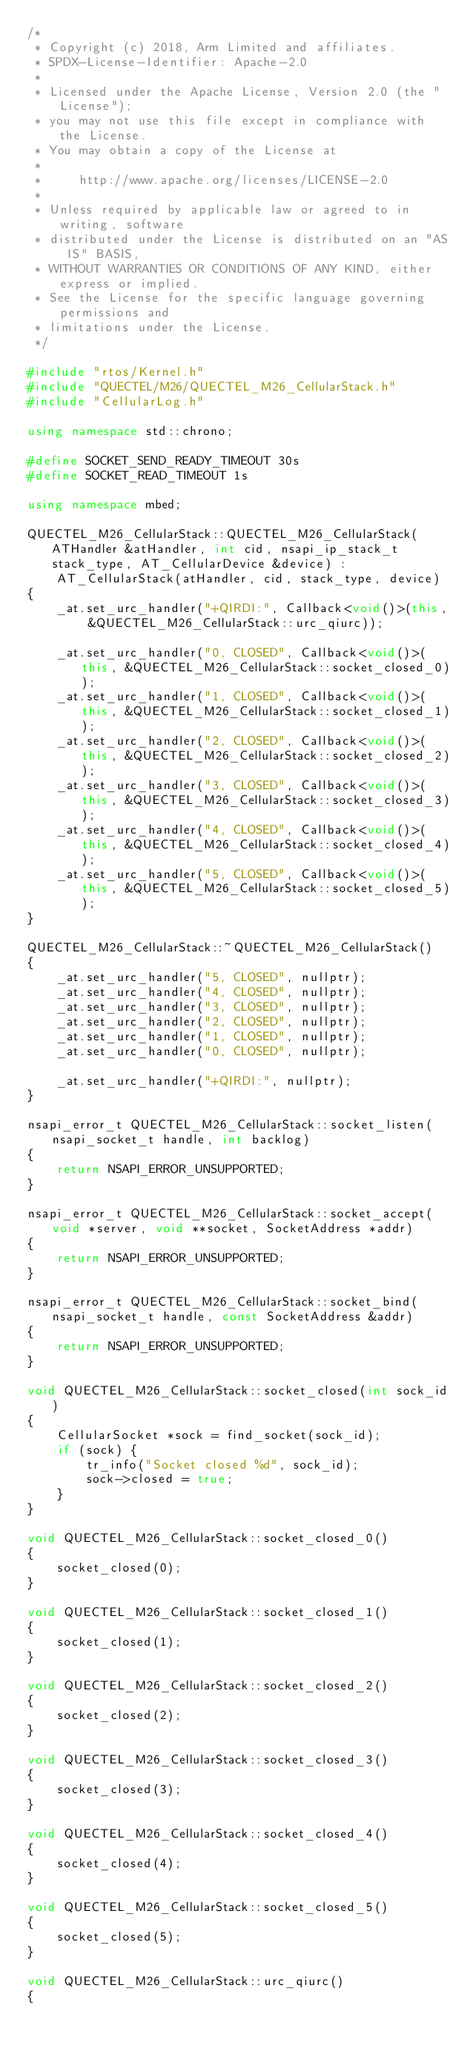<code> <loc_0><loc_0><loc_500><loc_500><_C++_>/*
 * Copyright (c) 2018, Arm Limited and affiliates.
 * SPDX-License-Identifier: Apache-2.0
 *
 * Licensed under the Apache License, Version 2.0 (the "License");
 * you may not use this file except in compliance with the License.
 * You may obtain a copy of the License at
 *
 *     http://www.apache.org/licenses/LICENSE-2.0
 *
 * Unless required by applicable law or agreed to in writing, software
 * distributed under the License is distributed on an "AS IS" BASIS,
 * WITHOUT WARRANTIES OR CONDITIONS OF ANY KIND, either express or implied.
 * See the License for the specific language governing permissions and
 * limitations under the License.
 */

#include "rtos/Kernel.h"
#include "QUECTEL/M26/QUECTEL_M26_CellularStack.h"
#include "CellularLog.h"

using namespace std::chrono;

#define SOCKET_SEND_READY_TIMEOUT 30s
#define SOCKET_READ_TIMEOUT 1s

using namespace mbed;

QUECTEL_M26_CellularStack::QUECTEL_M26_CellularStack(ATHandler &atHandler, int cid, nsapi_ip_stack_t stack_type, AT_CellularDevice &device) :
    AT_CellularStack(atHandler, cid, stack_type, device)
{
    _at.set_urc_handler("+QIRDI:", Callback<void()>(this, &QUECTEL_M26_CellularStack::urc_qiurc));

    _at.set_urc_handler("0, CLOSED", Callback<void()>(this, &QUECTEL_M26_CellularStack::socket_closed_0));
    _at.set_urc_handler("1, CLOSED", Callback<void()>(this, &QUECTEL_M26_CellularStack::socket_closed_1));
    _at.set_urc_handler("2, CLOSED", Callback<void()>(this, &QUECTEL_M26_CellularStack::socket_closed_2));
    _at.set_urc_handler("3, CLOSED", Callback<void()>(this, &QUECTEL_M26_CellularStack::socket_closed_3));
    _at.set_urc_handler("4, CLOSED", Callback<void()>(this, &QUECTEL_M26_CellularStack::socket_closed_4));
    _at.set_urc_handler("5, CLOSED", Callback<void()>(this, &QUECTEL_M26_CellularStack::socket_closed_5));
}

QUECTEL_M26_CellularStack::~QUECTEL_M26_CellularStack()
{
    _at.set_urc_handler("5, CLOSED", nullptr);
    _at.set_urc_handler("4, CLOSED", nullptr);
    _at.set_urc_handler("3, CLOSED", nullptr);
    _at.set_urc_handler("2, CLOSED", nullptr);
    _at.set_urc_handler("1, CLOSED", nullptr);
    _at.set_urc_handler("0, CLOSED", nullptr);

    _at.set_urc_handler("+QIRDI:", nullptr);
}

nsapi_error_t QUECTEL_M26_CellularStack::socket_listen(nsapi_socket_t handle, int backlog)
{
    return NSAPI_ERROR_UNSUPPORTED;
}

nsapi_error_t QUECTEL_M26_CellularStack::socket_accept(void *server, void **socket, SocketAddress *addr)
{
    return NSAPI_ERROR_UNSUPPORTED;
}

nsapi_error_t QUECTEL_M26_CellularStack::socket_bind(nsapi_socket_t handle, const SocketAddress &addr)
{
    return NSAPI_ERROR_UNSUPPORTED;
}

void QUECTEL_M26_CellularStack::socket_closed(int sock_id)
{
    CellularSocket *sock = find_socket(sock_id);
    if (sock) {
        tr_info("Socket closed %d", sock_id);
        sock->closed = true;
    }
}

void QUECTEL_M26_CellularStack::socket_closed_0()
{
    socket_closed(0);
}

void QUECTEL_M26_CellularStack::socket_closed_1()
{
    socket_closed(1);
}

void QUECTEL_M26_CellularStack::socket_closed_2()
{
    socket_closed(2);
}

void QUECTEL_M26_CellularStack::socket_closed_3()
{
    socket_closed(3);
}

void QUECTEL_M26_CellularStack::socket_closed_4()
{
    socket_closed(4);
}

void QUECTEL_M26_CellularStack::socket_closed_5()
{
    socket_closed(5);
}

void QUECTEL_M26_CellularStack::urc_qiurc()
{</code> 